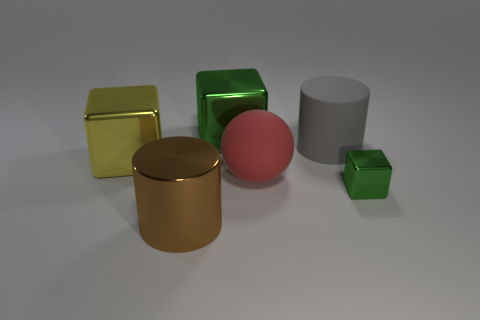Add 2 yellow cubes. How many objects exist? 8 Subtract all spheres. How many objects are left? 5 Subtract 0 green cylinders. How many objects are left? 6 Subtract all small brown things. Subtract all big red objects. How many objects are left? 5 Add 3 green objects. How many green objects are left? 5 Add 4 small yellow shiny spheres. How many small yellow shiny spheres exist? 4 